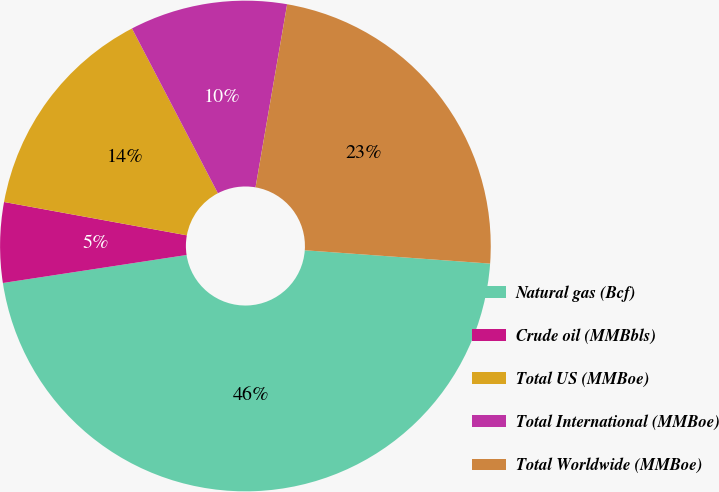Convert chart to OTSL. <chart><loc_0><loc_0><loc_500><loc_500><pie_chart><fcel>Natural gas (Bcf)<fcel>Crude oil (MMBbls)<fcel>Total US (MMBoe)<fcel>Total International (MMBoe)<fcel>Total Worldwide (MMBoe)<nl><fcel>46.45%<fcel>5.28%<fcel>14.48%<fcel>10.37%<fcel>23.42%<nl></chart> 